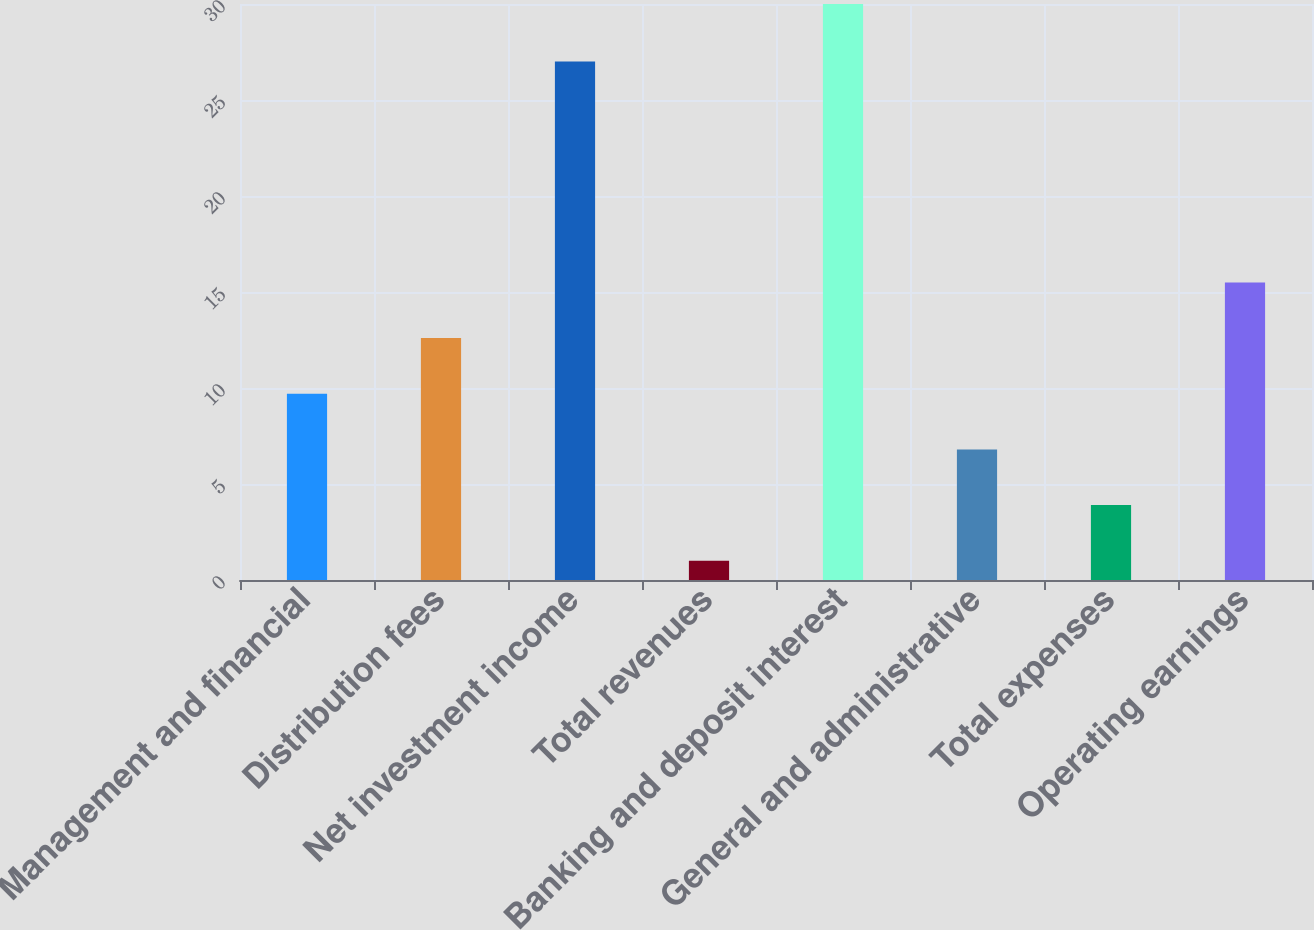Convert chart to OTSL. <chart><loc_0><loc_0><loc_500><loc_500><bar_chart><fcel>Management and financial<fcel>Distribution fees<fcel>Net investment income<fcel>Total revenues<fcel>Banking and deposit interest<fcel>General and administrative<fcel>Total expenses<fcel>Operating earnings<nl><fcel>9.7<fcel>12.6<fcel>27<fcel>1<fcel>30<fcel>6.8<fcel>3.9<fcel>15.5<nl></chart> 